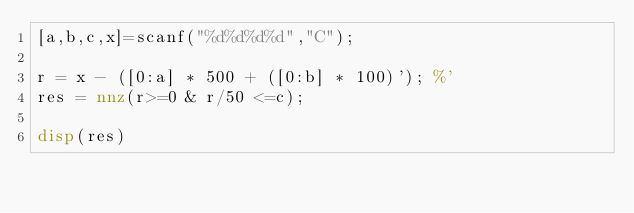Convert code to text. <code><loc_0><loc_0><loc_500><loc_500><_Octave_>[a,b,c,x]=scanf("%d%d%d%d","C");

r = x - ([0:a] * 500 + ([0:b] * 100)'); %'
res = nnz(r>=0 & r/50 <=c);

disp(res)</code> 